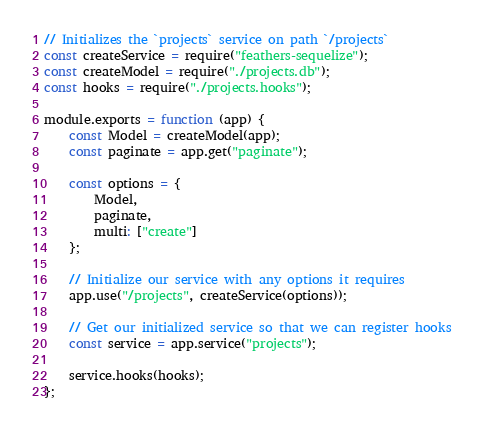<code> <loc_0><loc_0><loc_500><loc_500><_JavaScript_>// Initializes the `projects` service on path `/projects`
const createService = require("feathers-sequelize");
const createModel = require("./projects.db");
const hooks = require("./projects.hooks");

module.exports = function (app) {
    const Model = createModel(app);
    const paginate = app.get("paginate");

    const options = {
        Model,
        paginate,
        multi: ["create"]
    };

    // Initialize our service with any options it requires
    app.use("/projects", createService(options));

    // Get our initialized service so that we can register hooks
    const service = app.service("projects");

    service.hooks(hooks);
};
</code> 